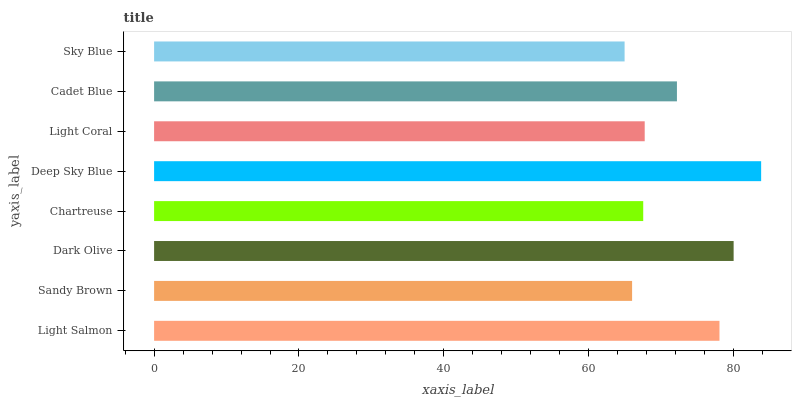Is Sky Blue the minimum?
Answer yes or no. Yes. Is Deep Sky Blue the maximum?
Answer yes or no. Yes. Is Sandy Brown the minimum?
Answer yes or no. No. Is Sandy Brown the maximum?
Answer yes or no. No. Is Light Salmon greater than Sandy Brown?
Answer yes or no. Yes. Is Sandy Brown less than Light Salmon?
Answer yes or no. Yes. Is Sandy Brown greater than Light Salmon?
Answer yes or no. No. Is Light Salmon less than Sandy Brown?
Answer yes or no. No. Is Cadet Blue the high median?
Answer yes or no. Yes. Is Light Coral the low median?
Answer yes or no. Yes. Is Light Coral the high median?
Answer yes or no. No. Is Deep Sky Blue the low median?
Answer yes or no. No. 